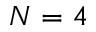<formula> <loc_0><loc_0><loc_500><loc_500>N = 4</formula> 